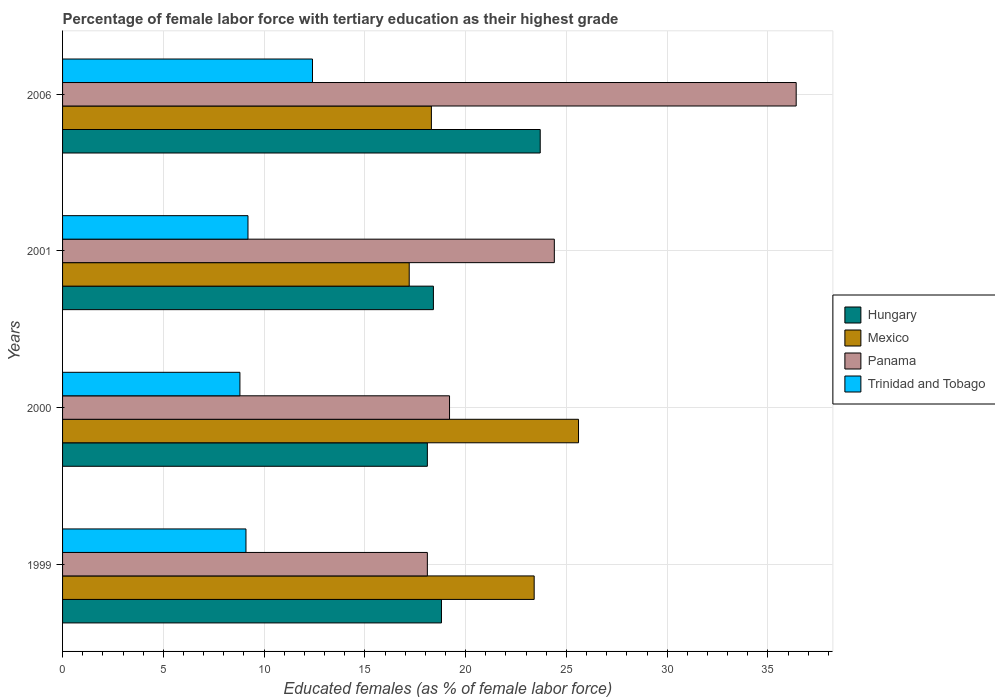Are the number of bars per tick equal to the number of legend labels?
Ensure brevity in your answer.  Yes. Are the number of bars on each tick of the Y-axis equal?
Ensure brevity in your answer.  Yes. How many bars are there on the 3rd tick from the bottom?
Keep it short and to the point. 4. What is the label of the 1st group of bars from the top?
Ensure brevity in your answer.  2006. In how many cases, is the number of bars for a given year not equal to the number of legend labels?
Give a very brief answer. 0. What is the percentage of female labor force with tertiary education in Mexico in 1999?
Keep it short and to the point. 23.4. Across all years, what is the maximum percentage of female labor force with tertiary education in Mexico?
Give a very brief answer. 25.6. Across all years, what is the minimum percentage of female labor force with tertiary education in Mexico?
Your answer should be compact. 17.2. In which year was the percentage of female labor force with tertiary education in Mexico maximum?
Your answer should be very brief. 2000. In which year was the percentage of female labor force with tertiary education in Panama minimum?
Make the answer very short. 1999. What is the total percentage of female labor force with tertiary education in Panama in the graph?
Give a very brief answer. 98.1. What is the difference between the percentage of female labor force with tertiary education in Mexico in 2000 and that in 2001?
Your answer should be very brief. 8.4. What is the difference between the percentage of female labor force with tertiary education in Mexico in 2000 and the percentage of female labor force with tertiary education in Trinidad and Tobago in 1999?
Your answer should be compact. 16.5. What is the average percentage of female labor force with tertiary education in Trinidad and Tobago per year?
Offer a very short reply. 9.88. In the year 2000, what is the difference between the percentage of female labor force with tertiary education in Hungary and percentage of female labor force with tertiary education in Mexico?
Offer a very short reply. -7.5. In how many years, is the percentage of female labor force with tertiary education in Panama greater than 20 %?
Provide a short and direct response. 2. What is the ratio of the percentage of female labor force with tertiary education in Hungary in 1999 to that in 2000?
Offer a very short reply. 1.04. Is the percentage of female labor force with tertiary education in Panama in 2000 less than that in 2001?
Your answer should be compact. Yes. Is the difference between the percentage of female labor force with tertiary education in Hungary in 1999 and 2000 greater than the difference between the percentage of female labor force with tertiary education in Mexico in 1999 and 2000?
Offer a very short reply. Yes. What is the difference between the highest and the second highest percentage of female labor force with tertiary education in Panama?
Offer a very short reply. 12. What is the difference between the highest and the lowest percentage of female labor force with tertiary education in Mexico?
Provide a short and direct response. 8.4. Is the sum of the percentage of female labor force with tertiary education in Panama in 2000 and 2006 greater than the maximum percentage of female labor force with tertiary education in Hungary across all years?
Your answer should be very brief. Yes. Is it the case that in every year, the sum of the percentage of female labor force with tertiary education in Panama and percentage of female labor force with tertiary education in Hungary is greater than the sum of percentage of female labor force with tertiary education in Trinidad and Tobago and percentage of female labor force with tertiary education in Mexico?
Provide a succinct answer. No. What does the 2nd bar from the bottom in 2000 represents?
Give a very brief answer. Mexico. Is it the case that in every year, the sum of the percentage of female labor force with tertiary education in Trinidad and Tobago and percentage of female labor force with tertiary education in Mexico is greater than the percentage of female labor force with tertiary education in Hungary?
Keep it short and to the point. Yes. How many bars are there?
Ensure brevity in your answer.  16. How many years are there in the graph?
Make the answer very short. 4. Are the values on the major ticks of X-axis written in scientific E-notation?
Provide a short and direct response. No. How are the legend labels stacked?
Provide a short and direct response. Vertical. What is the title of the graph?
Give a very brief answer. Percentage of female labor force with tertiary education as their highest grade. Does "Lower middle income" appear as one of the legend labels in the graph?
Give a very brief answer. No. What is the label or title of the X-axis?
Offer a terse response. Educated females (as % of female labor force). What is the Educated females (as % of female labor force) of Hungary in 1999?
Make the answer very short. 18.8. What is the Educated females (as % of female labor force) in Mexico in 1999?
Your answer should be very brief. 23.4. What is the Educated females (as % of female labor force) of Panama in 1999?
Offer a terse response. 18.1. What is the Educated females (as % of female labor force) of Trinidad and Tobago in 1999?
Provide a succinct answer. 9.1. What is the Educated females (as % of female labor force) in Hungary in 2000?
Your answer should be compact. 18.1. What is the Educated females (as % of female labor force) in Mexico in 2000?
Your answer should be compact. 25.6. What is the Educated females (as % of female labor force) of Panama in 2000?
Ensure brevity in your answer.  19.2. What is the Educated females (as % of female labor force) in Trinidad and Tobago in 2000?
Provide a succinct answer. 8.8. What is the Educated females (as % of female labor force) in Hungary in 2001?
Provide a short and direct response. 18.4. What is the Educated females (as % of female labor force) of Mexico in 2001?
Offer a very short reply. 17.2. What is the Educated females (as % of female labor force) of Panama in 2001?
Make the answer very short. 24.4. What is the Educated females (as % of female labor force) in Trinidad and Tobago in 2001?
Make the answer very short. 9.2. What is the Educated females (as % of female labor force) of Hungary in 2006?
Provide a succinct answer. 23.7. What is the Educated females (as % of female labor force) in Mexico in 2006?
Keep it short and to the point. 18.3. What is the Educated females (as % of female labor force) of Panama in 2006?
Offer a terse response. 36.4. What is the Educated females (as % of female labor force) of Trinidad and Tobago in 2006?
Your response must be concise. 12.4. Across all years, what is the maximum Educated females (as % of female labor force) in Hungary?
Keep it short and to the point. 23.7. Across all years, what is the maximum Educated females (as % of female labor force) in Mexico?
Offer a terse response. 25.6. Across all years, what is the maximum Educated females (as % of female labor force) in Panama?
Your answer should be compact. 36.4. Across all years, what is the maximum Educated females (as % of female labor force) in Trinidad and Tobago?
Offer a very short reply. 12.4. Across all years, what is the minimum Educated females (as % of female labor force) of Hungary?
Give a very brief answer. 18.1. Across all years, what is the minimum Educated females (as % of female labor force) in Mexico?
Ensure brevity in your answer.  17.2. Across all years, what is the minimum Educated females (as % of female labor force) in Panama?
Your response must be concise. 18.1. Across all years, what is the minimum Educated females (as % of female labor force) of Trinidad and Tobago?
Provide a succinct answer. 8.8. What is the total Educated females (as % of female labor force) in Hungary in the graph?
Keep it short and to the point. 79. What is the total Educated females (as % of female labor force) in Mexico in the graph?
Ensure brevity in your answer.  84.5. What is the total Educated females (as % of female labor force) of Panama in the graph?
Provide a short and direct response. 98.1. What is the total Educated females (as % of female labor force) of Trinidad and Tobago in the graph?
Keep it short and to the point. 39.5. What is the difference between the Educated females (as % of female labor force) of Mexico in 1999 and that in 2000?
Give a very brief answer. -2.2. What is the difference between the Educated females (as % of female labor force) of Trinidad and Tobago in 1999 and that in 2000?
Your answer should be compact. 0.3. What is the difference between the Educated females (as % of female labor force) in Panama in 1999 and that in 2001?
Offer a terse response. -6.3. What is the difference between the Educated females (as % of female labor force) of Mexico in 1999 and that in 2006?
Your answer should be compact. 5.1. What is the difference between the Educated females (as % of female labor force) in Panama in 1999 and that in 2006?
Offer a terse response. -18.3. What is the difference between the Educated females (as % of female labor force) in Trinidad and Tobago in 1999 and that in 2006?
Provide a short and direct response. -3.3. What is the difference between the Educated females (as % of female labor force) of Mexico in 2000 and that in 2001?
Your answer should be very brief. 8.4. What is the difference between the Educated females (as % of female labor force) of Panama in 2000 and that in 2001?
Your answer should be very brief. -5.2. What is the difference between the Educated females (as % of female labor force) of Trinidad and Tobago in 2000 and that in 2001?
Provide a succinct answer. -0.4. What is the difference between the Educated females (as % of female labor force) in Hungary in 2000 and that in 2006?
Keep it short and to the point. -5.6. What is the difference between the Educated females (as % of female labor force) of Mexico in 2000 and that in 2006?
Offer a very short reply. 7.3. What is the difference between the Educated females (as % of female labor force) in Panama in 2000 and that in 2006?
Give a very brief answer. -17.2. What is the difference between the Educated females (as % of female labor force) of Hungary in 2001 and that in 2006?
Your answer should be very brief. -5.3. What is the difference between the Educated females (as % of female labor force) of Mexico in 2001 and that in 2006?
Your answer should be compact. -1.1. What is the difference between the Educated females (as % of female labor force) in Panama in 2001 and that in 2006?
Give a very brief answer. -12. What is the difference between the Educated females (as % of female labor force) in Trinidad and Tobago in 2001 and that in 2006?
Give a very brief answer. -3.2. What is the difference between the Educated females (as % of female labor force) of Hungary in 1999 and the Educated females (as % of female labor force) of Trinidad and Tobago in 2000?
Give a very brief answer. 10. What is the difference between the Educated females (as % of female labor force) of Mexico in 1999 and the Educated females (as % of female labor force) of Panama in 2000?
Provide a succinct answer. 4.2. What is the difference between the Educated females (as % of female labor force) of Hungary in 1999 and the Educated females (as % of female labor force) of Panama in 2001?
Your answer should be compact. -5.6. What is the difference between the Educated females (as % of female labor force) of Hungary in 1999 and the Educated females (as % of female labor force) of Trinidad and Tobago in 2001?
Keep it short and to the point. 9.6. What is the difference between the Educated females (as % of female labor force) of Mexico in 1999 and the Educated females (as % of female labor force) of Panama in 2001?
Give a very brief answer. -1. What is the difference between the Educated females (as % of female labor force) of Mexico in 1999 and the Educated females (as % of female labor force) of Trinidad and Tobago in 2001?
Offer a terse response. 14.2. What is the difference between the Educated females (as % of female labor force) of Panama in 1999 and the Educated females (as % of female labor force) of Trinidad and Tobago in 2001?
Your answer should be very brief. 8.9. What is the difference between the Educated females (as % of female labor force) of Hungary in 1999 and the Educated females (as % of female labor force) of Panama in 2006?
Give a very brief answer. -17.6. What is the difference between the Educated females (as % of female labor force) in Hungary in 1999 and the Educated females (as % of female labor force) in Trinidad and Tobago in 2006?
Ensure brevity in your answer.  6.4. What is the difference between the Educated females (as % of female labor force) of Mexico in 1999 and the Educated females (as % of female labor force) of Trinidad and Tobago in 2006?
Offer a terse response. 11. What is the difference between the Educated females (as % of female labor force) of Panama in 1999 and the Educated females (as % of female labor force) of Trinidad and Tobago in 2006?
Your answer should be very brief. 5.7. What is the difference between the Educated females (as % of female labor force) in Panama in 2000 and the Educated females (as % of female labor force) in Trinidad and Tobago in 2001?
Your response must be concise. 10. What is the difference between the Educated females (as % of female labor force) of Hungary in 2000 and the Educated females (as % of female labor force) of Panama in 2006?
Ensure brevity in your answer.  -18.3. What is the difference between the Educated females (as % of female labor force) in Mexico in 2000 and the Educated females (as % of female labor force) in Panama in 2006?
Give a very brief answer. -10.8. What is the difference between the Educated females (as % of female labor force) in Hungary in 2001 and the Educated females (as % of female labor force) in Panama in 2006?
Provide a succinct answer. -18. What is the difference between the Educated females (as % of female labor force) of Mexico in 2001 and the Educated females (as % of female labor force) of Panama in 2006?
Your answer should be compact. -19.2. What is the difference between the Educated females (as % of female labor force) of Panama in 2001 and the Educated females (as % of female labor force) of Trinidad and Tobago in 2006?
Give a very brief answer. 12. What is the average Educated females (as % of female labor force) of Hungary per year?
Your answer should be compact. 19.75. What is the average Educated females (as % of female labor force) in Mexico per year?
Offer a very short reply. 21.12. What is the average Educated females (as % of female labor force) of Panama per year?
Make the answer very short. 24.52. What is the average Educated females (as % of female labor force) in Trinidad and Tobago per year?
Your answer should be very brief. 9.88. In the year 1999, what is the difference between the Educated females (as % of female labor force) in Hungary and Educated females (as % of female labor force) in Panama?
Your response must be concise. 0.7. In the year 1999, what is the difference between the Educated females (as % of female labor force) of Hungary and Educated females (as % of female labor force) of Trinidad and Tobago?
Your response must be concise. 9.7. In the year 1999, what is the difference between the Educated females (as % of female labor force) of Mexico and Educated females (as % of female labor force) of Panama?
Your answer should be compact. 5.3. In the year 1999, what is the difference between the Educated females (as % of female labor force) of Mexico and Educated females (as % of female labor force) of Trinidad and Tobago?
Ensure brevity in your answer.  14.3. In the year 2000, what is the difference between the Educated females (as % of female labor force) in Mexico and Educated females (as % of female labor force) in Trinidad and Tobago?
Your answer should be compact. 16.8. In the year 2000, what is the difference between the Educated females (as % of female labor force) in Panama and Educated females (as % of female labor force) in Trinidad and Tobago?
Make the answer very short. 10.4. In the year 2001, what is the difference between the Educated females (as % of female labor force) in Hungary and Educated females (as % of female labor force) in Trinidad and Tobago?
Make the answer very short. 9.2. In the year 2006, what is the difference between the Educated females (as % of female labor force) in Hungary and Educated females (as % of female labor force) in Mexico?
Give a very brief answer. 5.4. In the year 2006, what is the difference between the Educated females (as % of female labor force) of Mexico and Educated females (as % of female labor force) of Panama?
Provide a succinct answer. -18.1. What is the ratio of the Educated females (as % of female labor force) of Hungary in 1999 to that in 2000?
Keep it short and to the point. 1.04. What is the ratio of the Educated females (as % of female labor force) of Mexico in 1999 to that in 2000?
Ensure brevity in your answer.  0.91. What is the ratio of the Educated females (as % of female labor force) in Panama in 1999 to that in 2000?
Provide a short and direct response. 0.94. What is the ratio of the Educated females (as % of female labor force) of Trinidad and Tobago in 1999 to that in 2000?
Offer a very short reply. 1.03. What is the ratio of the Educated females (as % of female labor force) in Hungary in 1999 to that in 2001?
Your answer should be compact. 1.02. What is the ratio of the Educated females (as % of female labor force) in Mexico in 1999 to that in 2001?
Your response must be concise. 1.36. What is the ratio of the Educated females (as % of female labor force) in Panama in 1999 to that in 2001?
Offer a very short reply. 0.74. What is the ratio of the Educated females (as % of female labor force) of Hungary in 1999 to that in 2006?
Keep it short and to the point. 0.79. What is the ratio of the Educated females (as % of female labor force) in Mexico in 1999 to that in 2006?
Your answer should be compact. 1.28. What is the ratio of the Educated females (as % of female labor force) in Panama in 1999 to that in 2006?
Ensure brevity in your answer.  0.5. What is the ratio of the Educated females (as % of female labor force) of Trinidad and Tobago in 1999 to that in 2006?
Offer a terse response. 0.73. What is the ratio of the Educated females (as % of female labor force) in Hungary in 2000 to that in 2001?
Provide a succinct answer. 0.98. What is the ratio of the Educated females (as % of female labor force) in Mexico in 2000 to that in 2001?
Ensure brevity in your answer.  1.49. What is the ratio of the Educated females (as % of female labor force) in Panama in 2000 to that in 2001?
Make the answer very short. 0.79. What is the ratio of the Educated females (as % of female labor force) in Trinidad and Tobago in 2000 to that in 2001?
Give a very brief answer. 0.96. What is the ratio of the Educated females (as % of female labor force) of Hungary in 2000 to that in 2006?
Provide a succinct answer. 0.76. What is the ratio of the Educated females (as % of female labor force) of Mexico in 2000 to that in 2006?
Offer a very short reply. 1.4. What is the ratio of the Educated females (as % of female labor force) of Panama in 2000 to that in 2006?
Ensure brevity in your answer.  0.53. What is the ratio of the Educated females (as % of female labor force) in Trinidad and Tobago in 2000 to that in 2006?
Make the answer very short. 0.71. What is the ratio of the Educated females (as % of female labor force) of Hungary in 2001 to that in 2006?
Make the answer very short. 0.78. What is the ratio of the Educated females (as % of female labor force) of Mexico in 2001 to that in 2006?
Offer a terse response. 0.94. What is the ratio of the Educated females (as % of female labor force) of Panama in 2001 to that in 2006?
Offer a very short reply. 0.67. What is the ratio of the Educated females (as % of female labor force) in Trinidad and Tobago in 2001 to that in 2006?
Your answer should be compact. 0.74. What is the difference between the highest and the second highest Educated females (as % of female labor force) in Hungary?
Offer a very short reply. 4.9. What is the difference between the highest and the second highest Educated females (as % of female labor force) in Trinidad and Tobago?
Provide a succinct answer. 3.2. What is the difference between the highest and the lowest Educated females (as % of female labor force) in Hungary?
Offer a terse response. 5.6. 